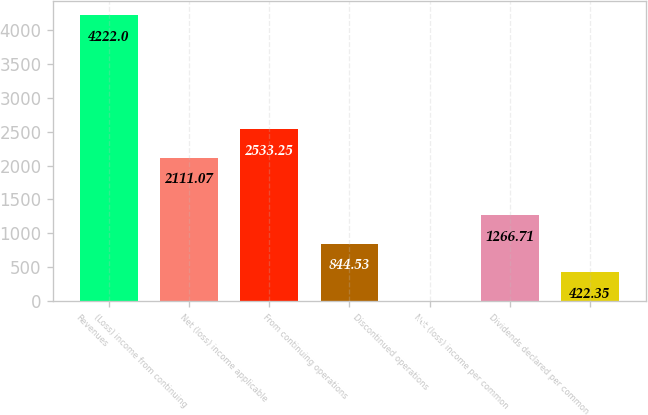<chart> <loc_0><loc_0><loc_500><loc_500><bar_chart><fcel>Revenues<fcel>(Loss) income from continuing<fcel>Net (loss) income applicable<fcel>From continuing operations<fcel>Discontinued operations<fcel>Net (loss) income per common<fcel>Dividends declared per common<nl><fcel>4222<fcel>2111.07<fcel>2533.25<fcel>844.53<fcel>0.17<fcel>1266.71<fcel>422.35<nl></chart> 